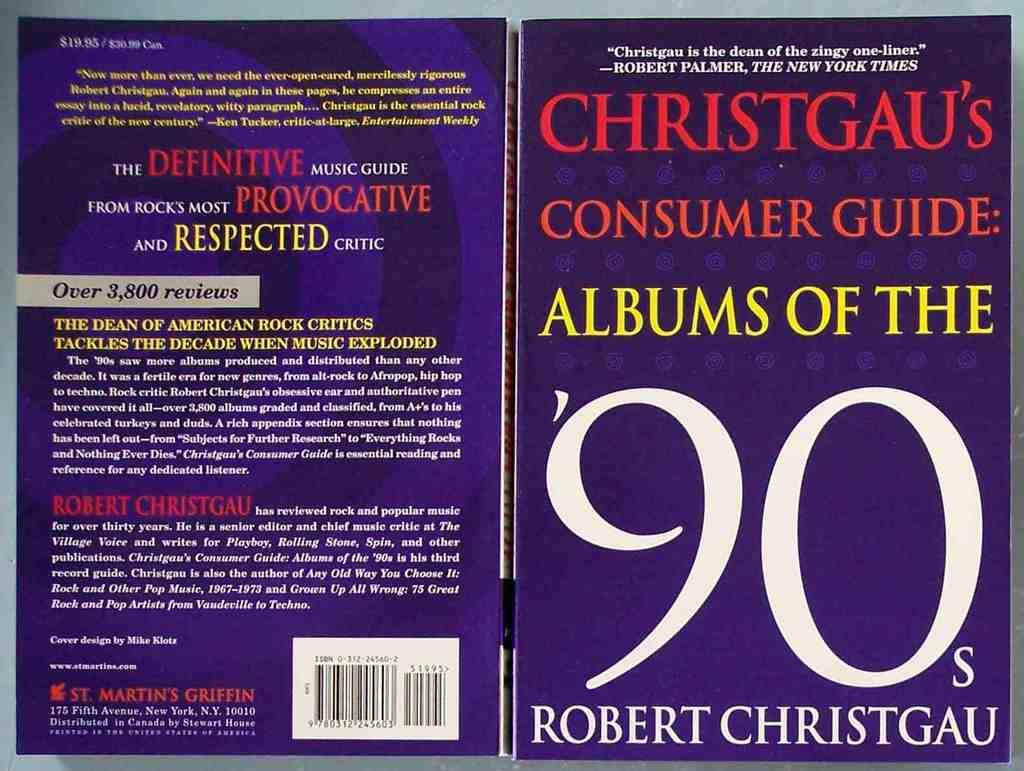<image>
Write a terse but informative summary of the picture. A cover of Christgau's Consumer Guide: Albums of the '90's by Robert Christgau. 